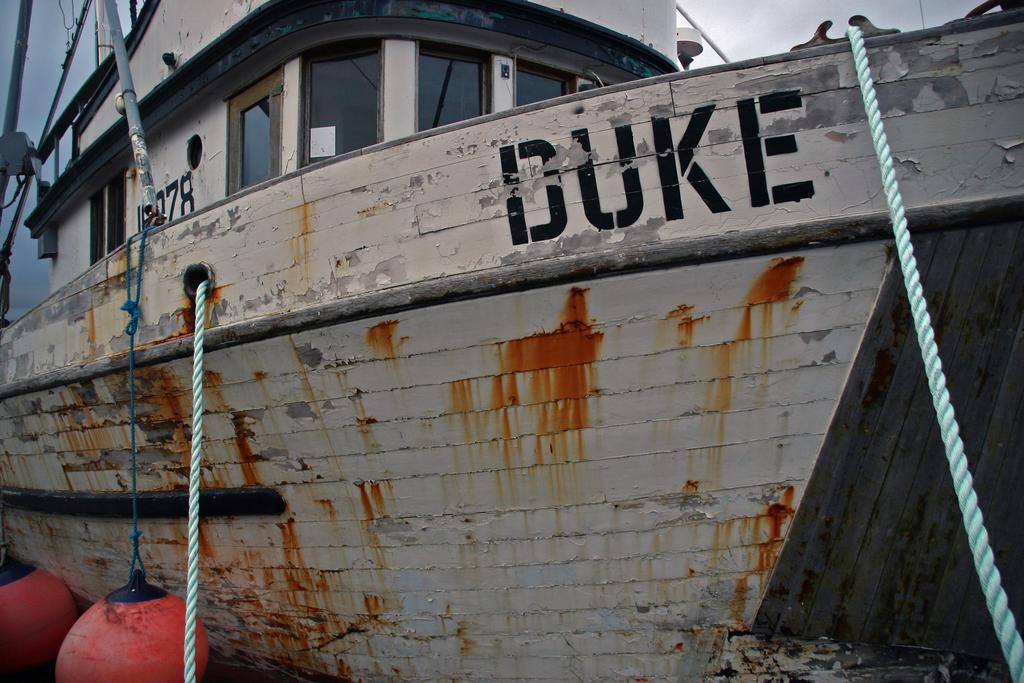Can you describe this image briefly? Here I can see a ship along with the windows, metal poles and ropes. At the top of the image I can see the sky. On this ship there is some text. In the bottom left-hand corner there are two red color objects. 